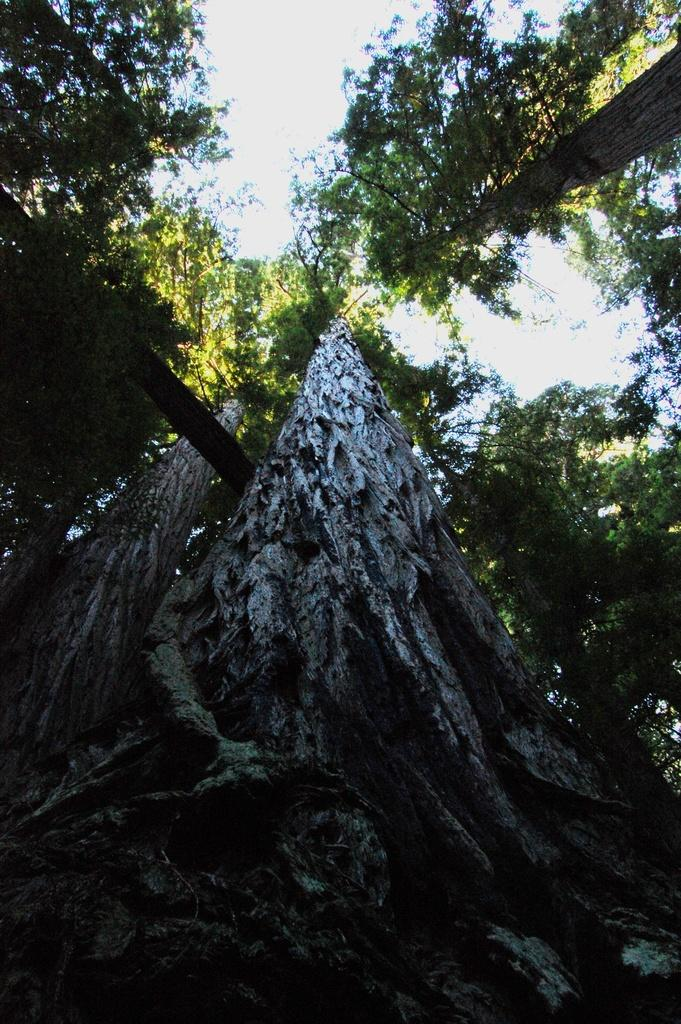What type of vegetation is present in the image? There are tall trees in the image. What is the condition of the sky in the image? The sky is cloudy in the image. Can you tell me what the father is saying to the shop owner in the image? There is no father or shop owner present in the image; it only features tall trees and a cloudy sky. 